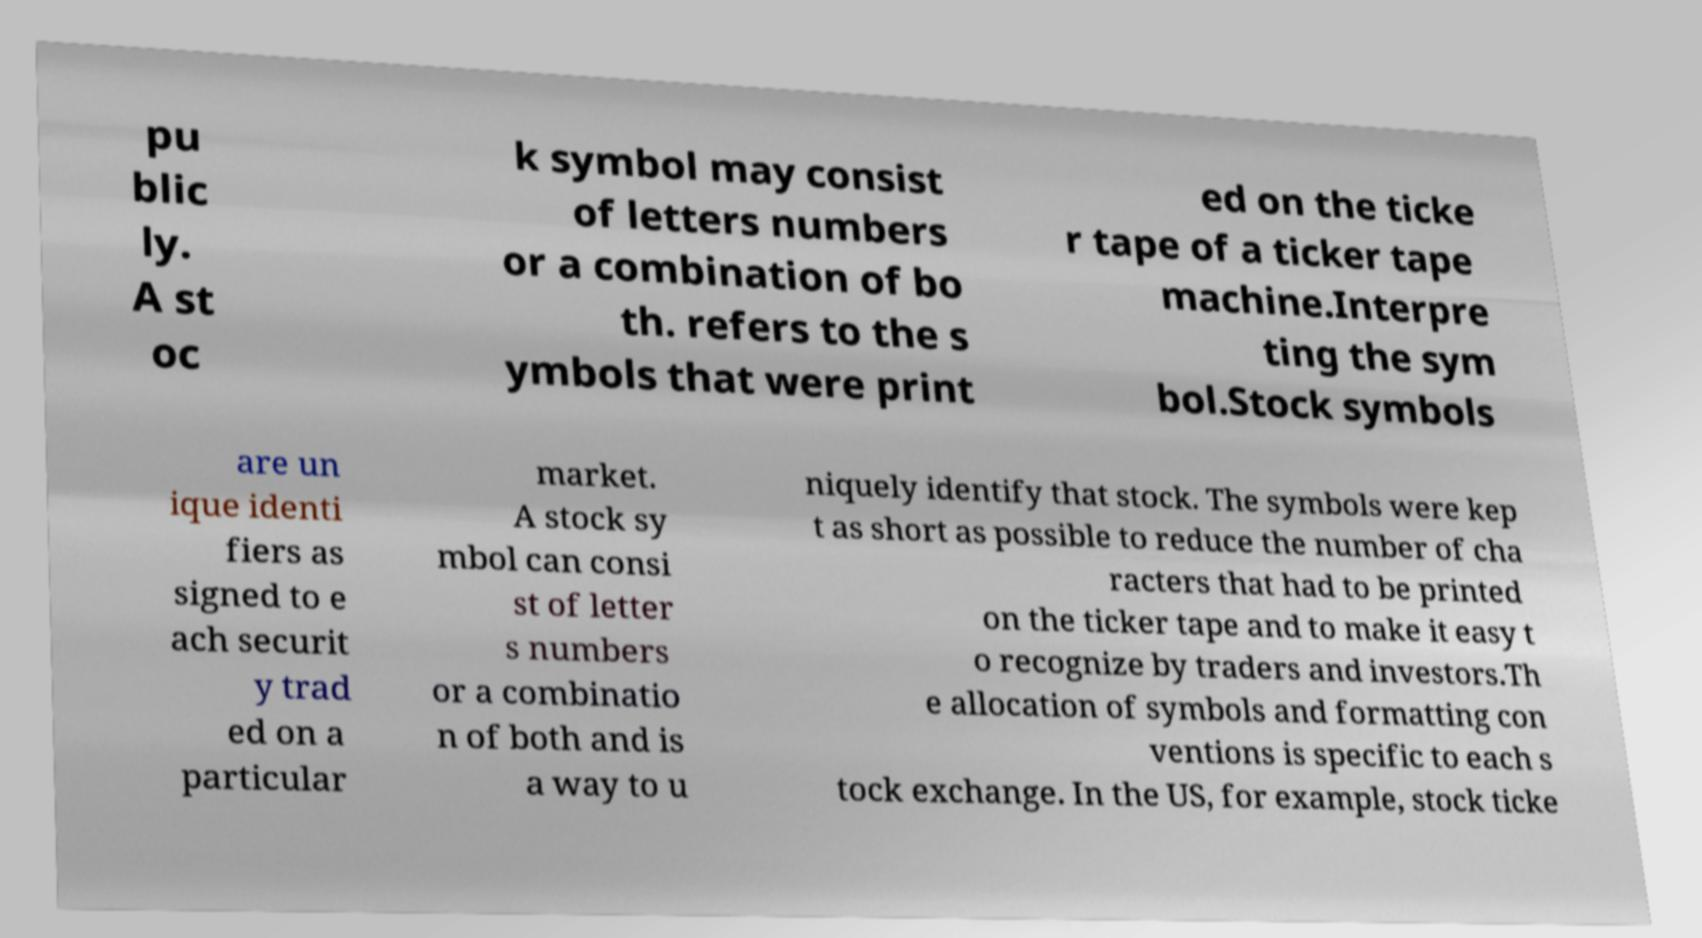For documentation purposes, I need the text within this image transcribed. Could you provide that? pu blic ly. A st oc k symbol may consist of letters numbers or a combination of bo th. refers to the s ymbols that were print ed on the ticke r tape of a ticker tape machine.Interpre ting the sym bol.Stock symbols are un ique identi fiers as signed to e ach securit y trad ed on a particular market. A stock sy mbol can consi st of letter s numbers or a combinatio n of both and is a way to u niquely identify that stock. The symbols were kep t as short as possible to reduce the number of cha racters that had to be printed on the ticker tape and to make it easy t o recognize by traders and investors.Th e allocation of symbols and formatting con ventions is specific to each s tock exchange. In the US, for example, stock ticke 